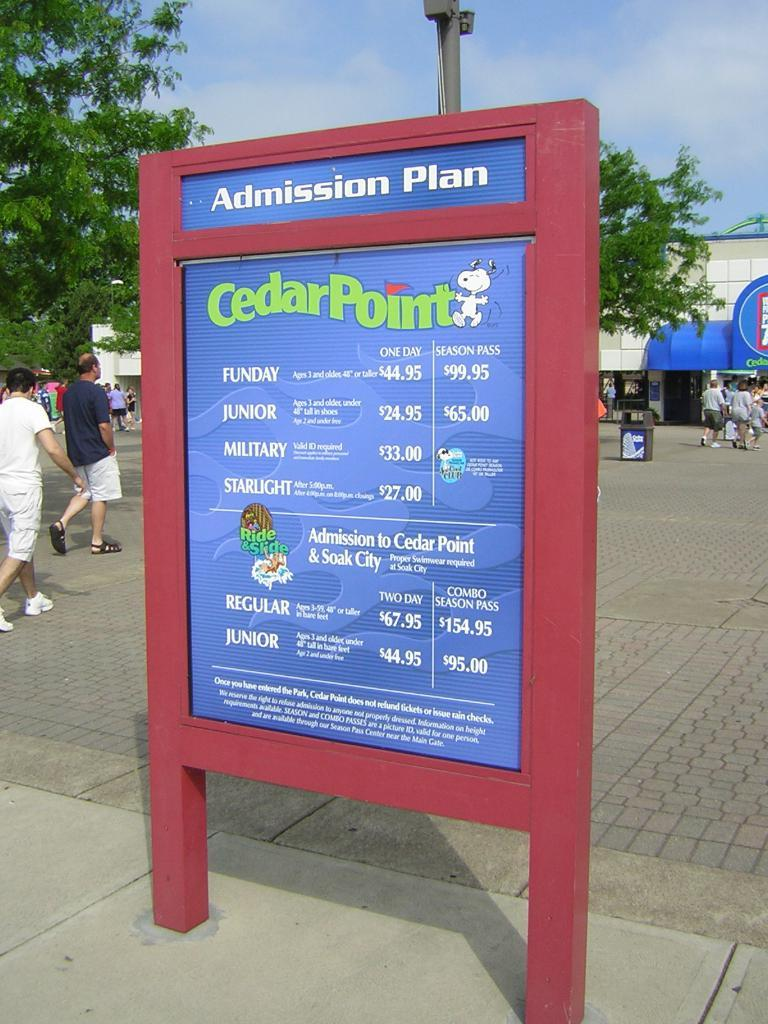What is written on the board in the image? There is a board with text in the image. Who or what can be seen in the image besides the board? There are people, a pole, trees, and a dustbin visible in the image. What is the purpose of the pole in the image? The purpose of the pole is not specified in the image, but it could be a utility pole or a signpost. What is the natural element present in the background of the image? There are trees in the background of the image. What is used for waste disposal in the image? There is a dustbin in the image for waste disposal. What can be seen in the sky in the background of the image? The sky is visible in the background of the image, but no specific details about the sky are mentioned. What is the name of the actor who plays the lead role in the image? There is no actor or lead role in the image, as it is a photograph of a board with text and other objects in a setting. 